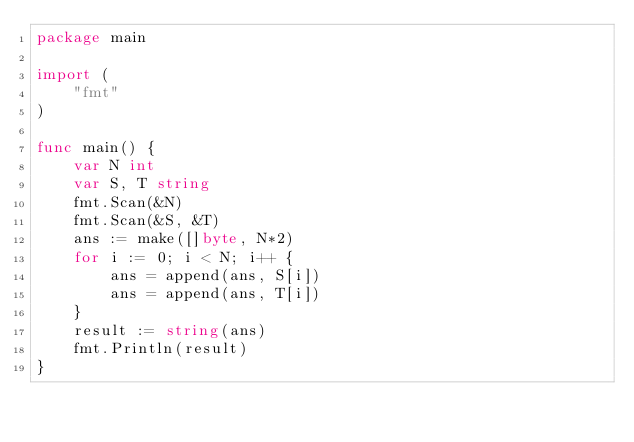<code> <loc_0><loc_0><loc_500><loc_500><_Go_>package main

import (
	"fmt"
)

func main() {
	var N int
	var S, T string
	fmt.Scan(&N)
	fmt.Scan(&S, &T)
	ans := make([]byte, N*2)
	for i := 0; i < N; i++ {
		ans = append(ans, S[i])
		ans = append(ans, T[i])
	}
	result := string(ans)
	fmt.Println(result)
}
</code> 